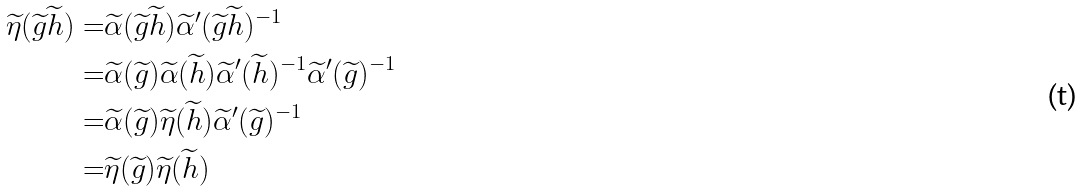Convert formula to latex. <formula><loc_0><loc_0><loc_500><loc_500>\widetilde { \eta } ( \widetilde { g } \widetilde { h } ) = & \widetilde { \alpha } ( \widetilde { g } \widetilde { h } ) \widetilde { \alpha } ^ { \prime } ( \widetilde { g } \widetilde { h } ) ^ { - 1 } \\ = & \widetilde { \alpha } ( \widetilde { g } ) \widetilde { \alpha } ( \widetilde { h } ) \widetilde { \alpha } ^ { \prime } ( \widetilde { h } ) ^ { - 1 } \widetilde { \alpha } ^ { \prime } ( \widetilde { g } ) ^ { - 1 } \\ = & \widetilde { \alpha } ( \widetilde { g } ) \widetilde { \eta } ( \widetilde { h } ) \widetilde { \alpha } ^ { \prime } ( \widetilde { g } ) ^ { - 1 } \\ = & \widetilde { \eta } ( \widetilde { g } ) \widetilde { \eta } ( \widetilde { h } )</formula> 